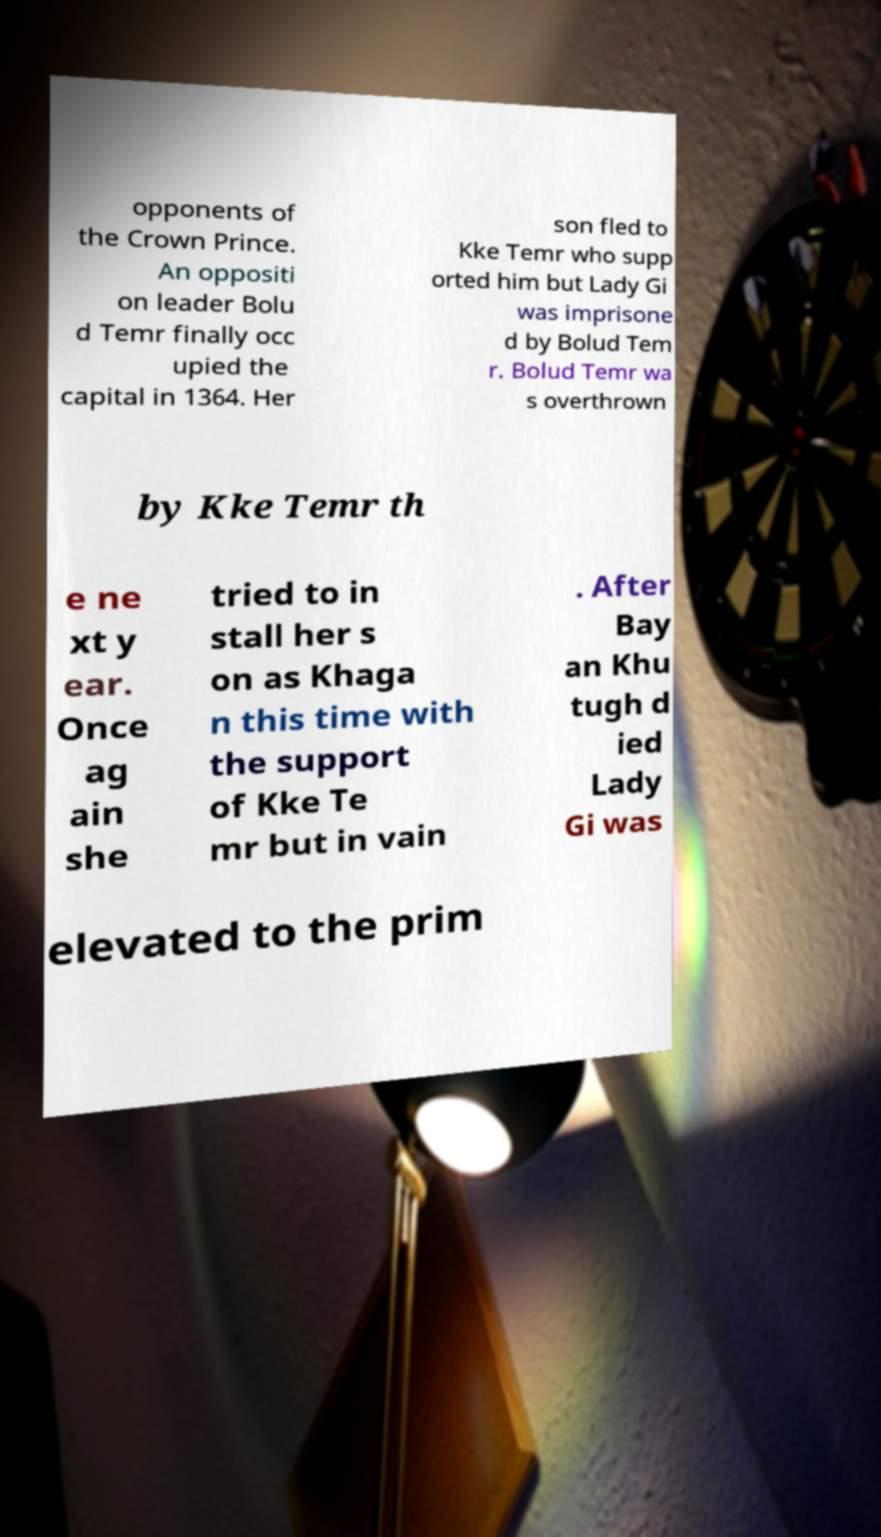There's text embedded in this image that I need extracted. Can you transcribe it verbatim? opponents of the Crown Prince. An oppositi on leader Bolu d Temr finally occ upied the capital in 1364. Her son fled to Kke Temr who supp orted him but Lady Gi was imprisone d by Bolud Tem r. Bolud Temr wa s overthrown by Kke Temr th e ne xt y ear. Once ag ain she tried to in stall her s on as Khaga n this time with the support of Kke Te mr but in vain . After Bay an Khu tugh d ied Lady Gi was elevated to the prim 